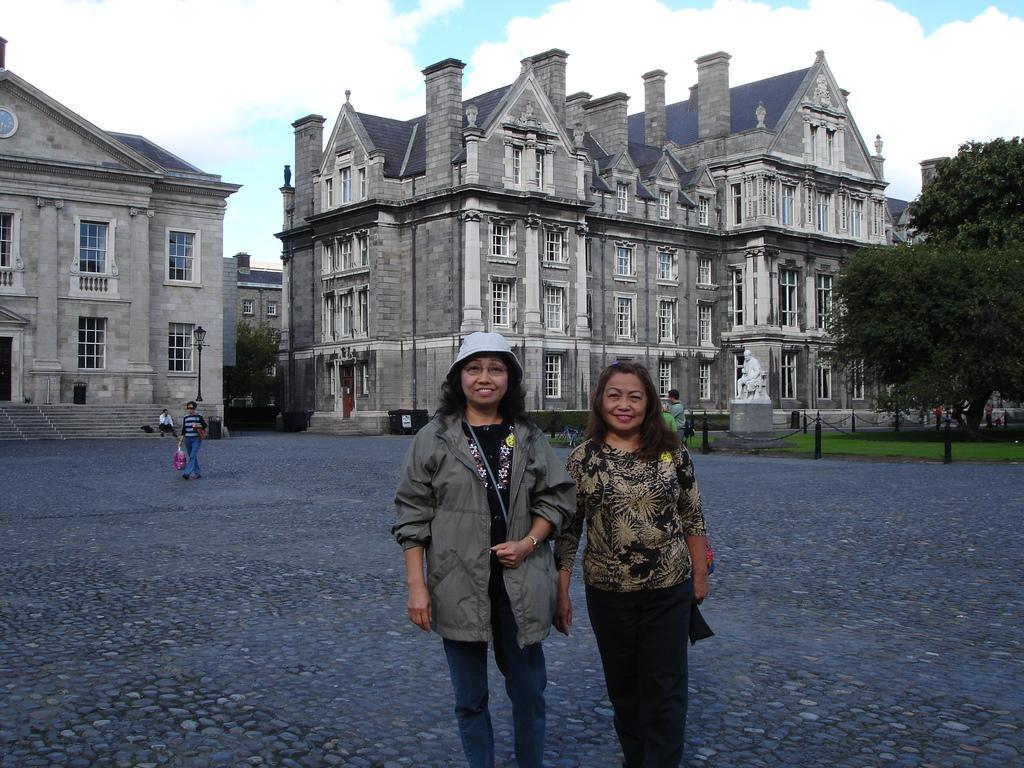How would you summarize this image in a sentence or two? In this image I can see two people standing and smiling. Back I can see buildings,glass windows,stairs,white statue,fencing and trees. The sky is in blue and white color. 